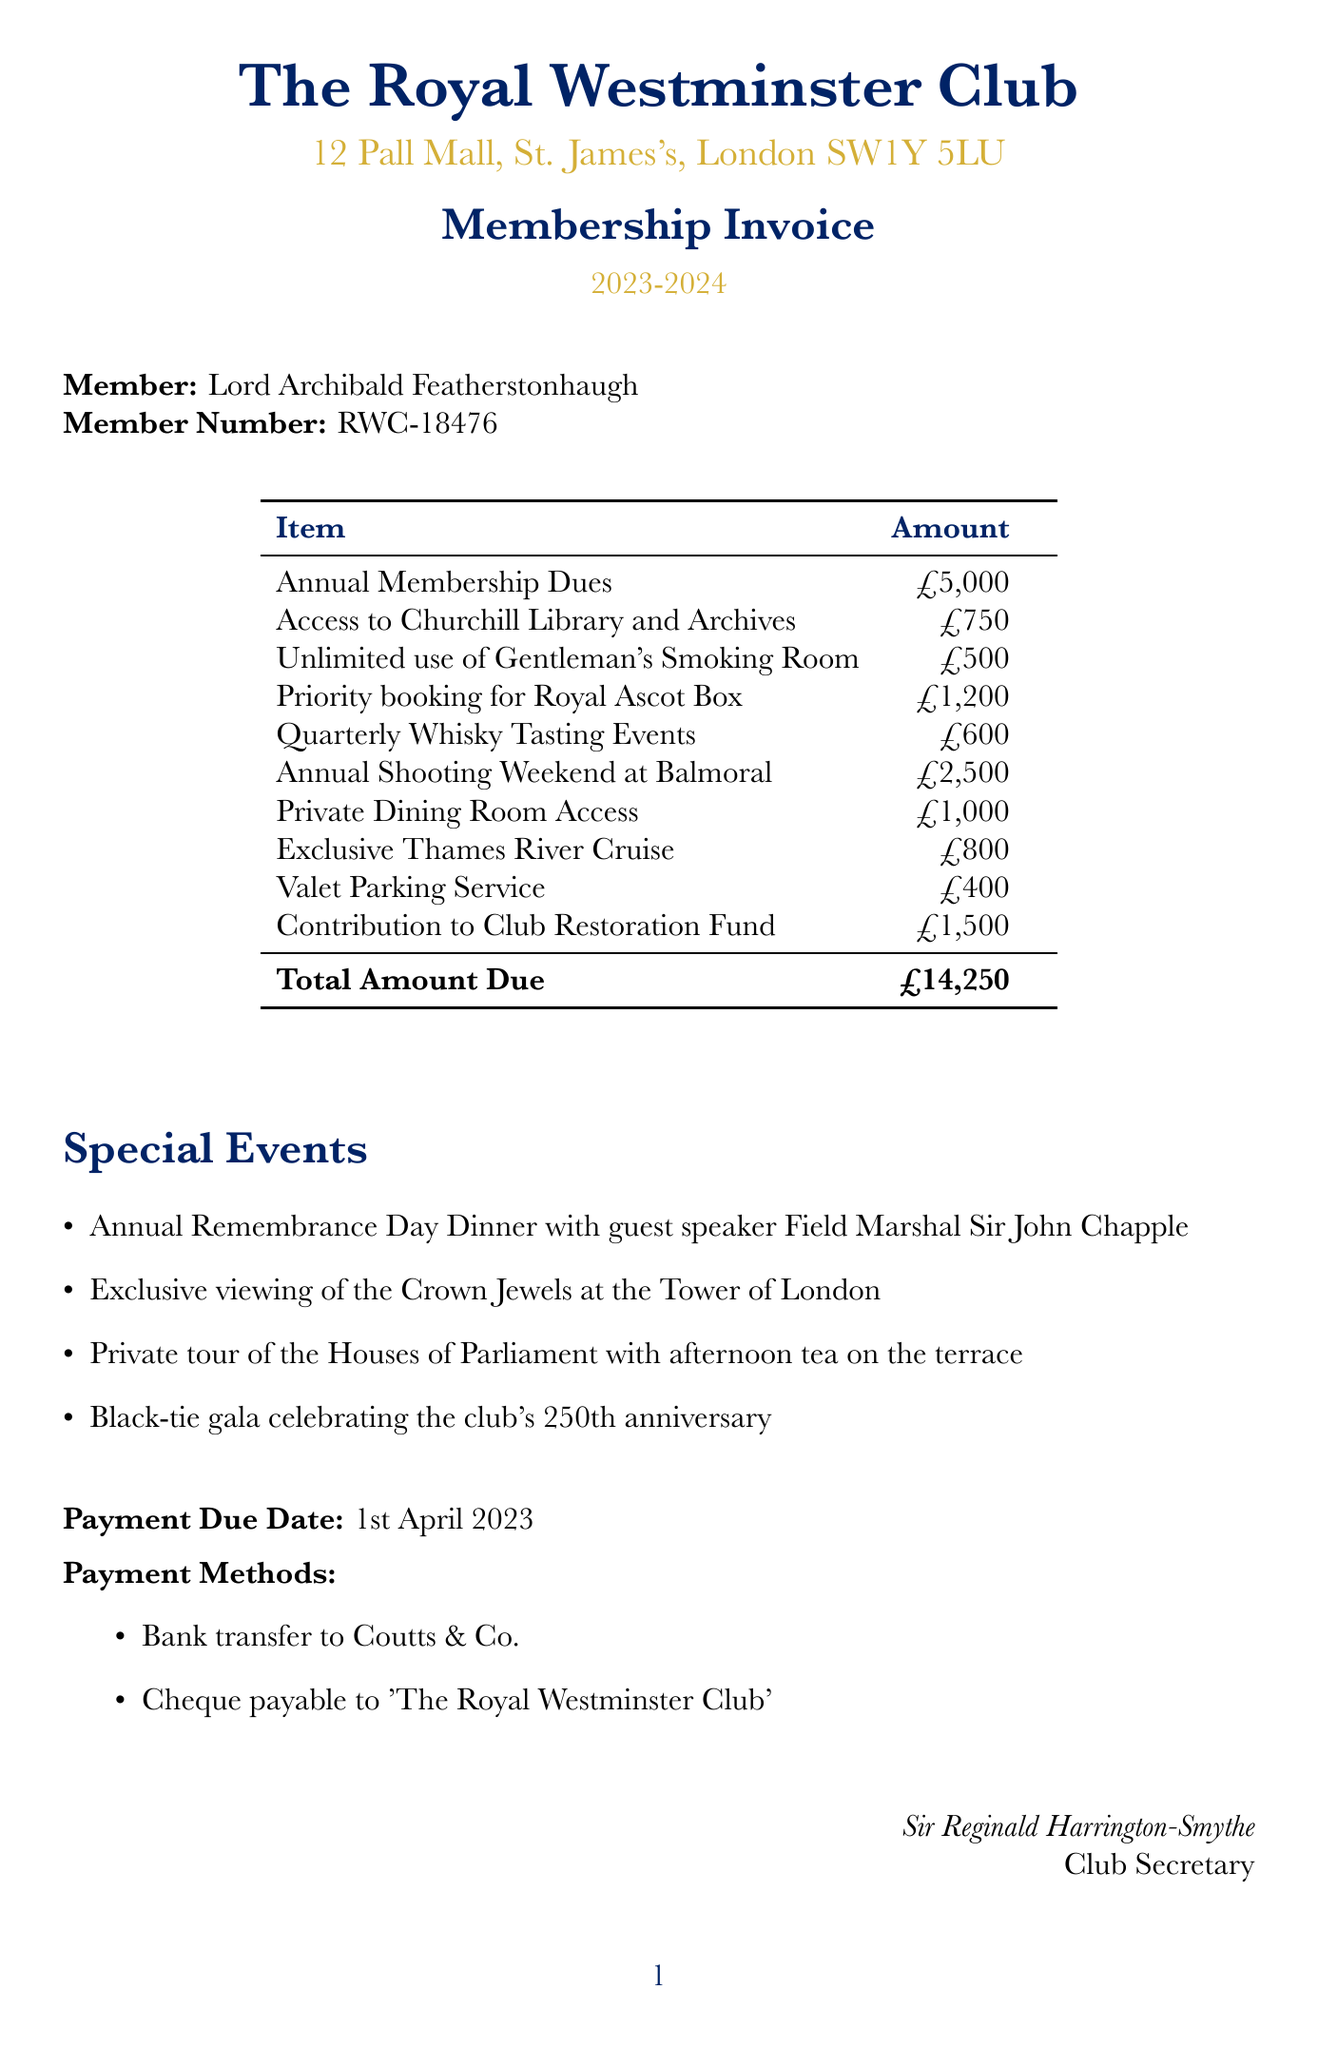what is the total amount due? The total amount due is listed at the bottom of the itemized bill.
Answer: £14,250 who is the club secretary? The name of the club secretary is given at the end of the document.
Answer: Sir Reginald Harrington-Smythe when is the payment due date? The document specifies the due date for payment.
Answer: 1st April 2023 how much are the annual membership dues? The first item in the itemized bill indicates the cost of membership dues.
Answer: £5,000 what special event features a guest speaker? One of the special events specifically mentions a guest speaker.
Answer: Annual Remembrance Day Dinner with guest speaker Field Marshal Sir John Chapple what is the item listed for the contribution to the restoration fund? The contribution to the Club Restoration Fund is specified in the itemized bill.
Answer: Contribution to Club Restoration Fund how much does access to the Churchill Library and Archives cost? The amount listed next to access to this facility is found in the itemized bill.
Answer: £750 which payment method is NOT mentioned in the document? By evaluating the payment methods mentioned in the document, one can identify any omissions.
Answer: Cash 